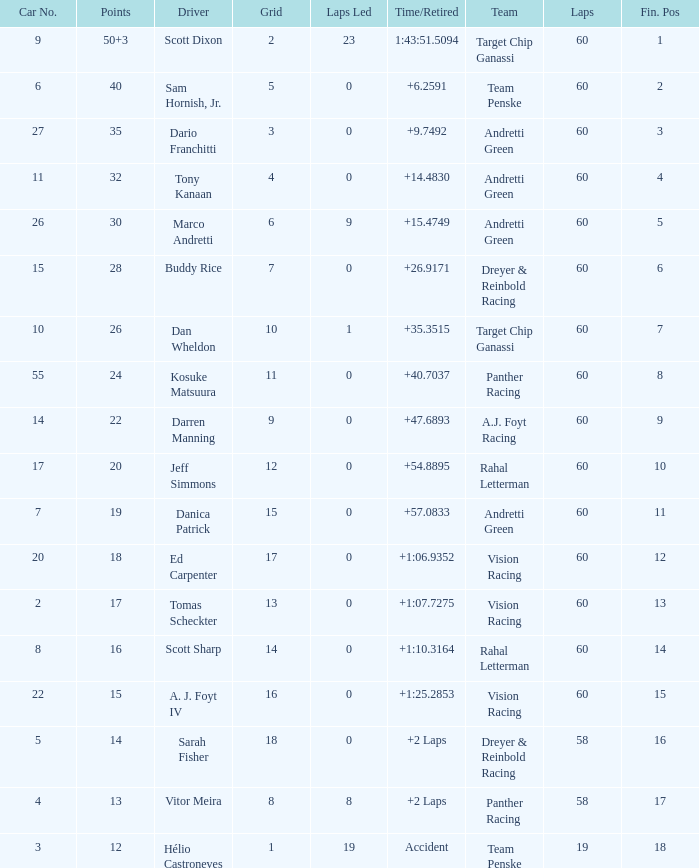Name the team for scott dixon Target Chip Ganassi. 